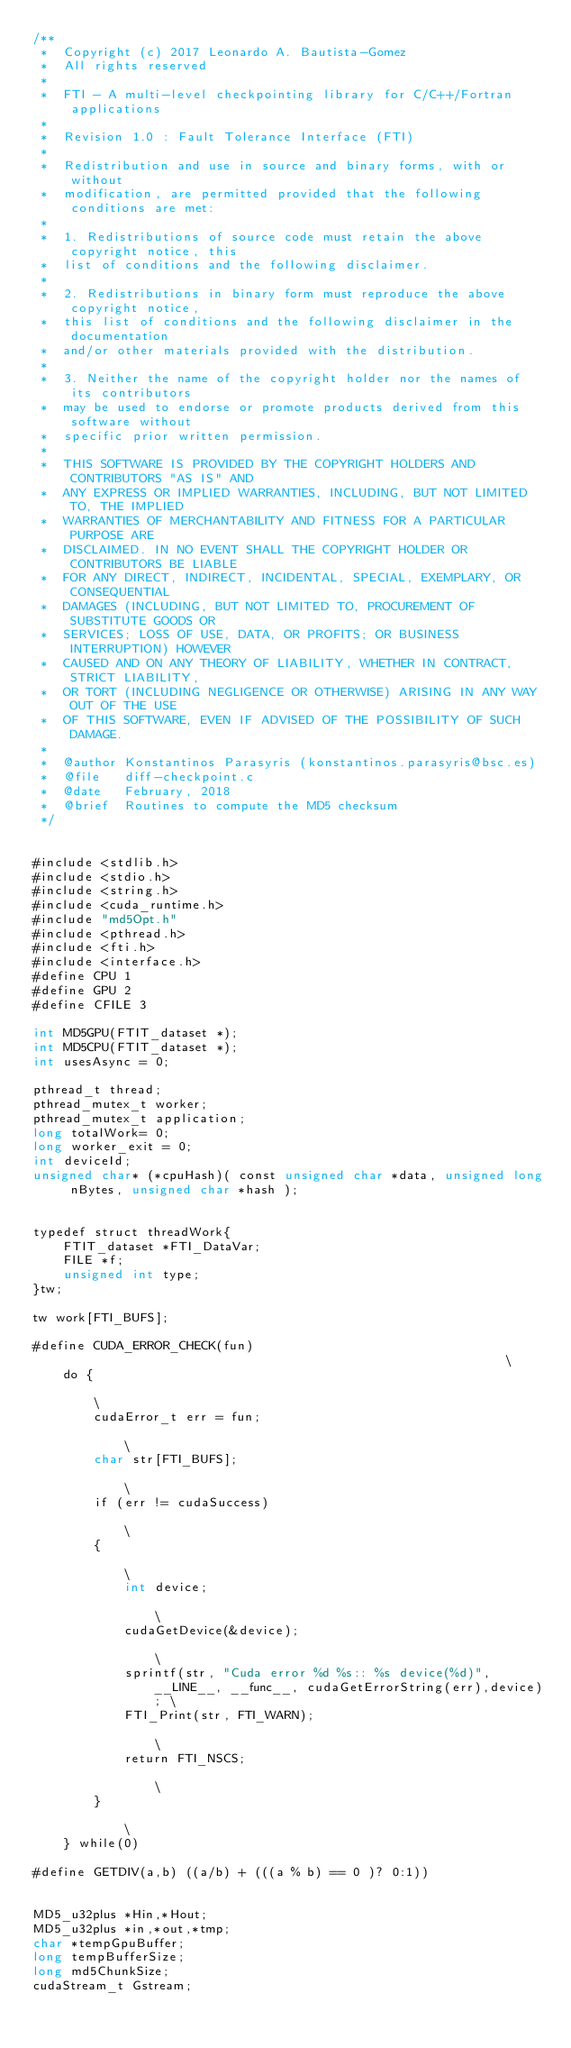<code> <loc_0><loc_0><loc_500><loc_500><_Cuda_>/**
 *  Copyright (c) 2017 Leonardo A. Bautista-Gomez
 *  All rights reserved
 *
 *  FTI - A multi-level checkpointing library for C/C++/Fortran applications
 *
 *  Revision 1.0 : Fault Tolerance Interface (FTI)
 *
 *  Redistribution and use in source and binary forms, with or without
 *  modification, are permitted provided that the following conditions are met:
 *
 *  1. Redistributions of source code must retain the above copyright notice, this
 *  list of conditions and the following disclaimer.
 *
 *  2. Redistributions in binary form must reproduce the above copyright notice,
 *  this list of conditions and the following disclaimer in the documentation
 *  and/or other materials provided with the distribution.
 *
 *  3. Neither the name of the copyright holder nor the names of its contributors
 *  may be used to endorse or promote products derived from this software without
 *  specific prior written permission.
 *
 *  THIS SOFTWARE IS PROVIDED BY THE COPYRIGHT HOLDERS AND CONTRIBUTORS "AS IS" AND
 *  ANY EXPRESS OR IMPLIED WARRANTIES, INCLUDING, BUT NOT LIMITED TO, THE IMPLIED
 *  WARRANTIES OF MERCHANTABILITY AND FITNESS FOR A PARTICULAR PURPOSE ARE
 *  DISCLAIMED. IN NO EVENT SHALL THE COPYRIGHT HOLDER OR CONTRIBUTORS BE LIABLE
 *  FOR ANY DIRECT, INDIRECT, INCIDENTAL, SPECIAL, EXEMPLARY, OR CONSEQUENTIAL
 *  DAMAGES (INCLUDING, BUT NOT LIMITED TO, PROCUREMENT OF SUBSTITUTE GOODS OR
 *  SERVICES; LOSS OF USE, DATA, OR PROFITS; OR BUSINESS INTERRUPTION) HOWEVER
 *  CAUSED AND ON ANY THEORY OF LIABILITY, WHETHER IN CONTRACT, STRICT LIABILITY,
 *  OR TORT (INCLUDING NEGLIGENCE OR OTHERWISE) ARISING IN ANY WAY OUT OF THE USE
 *  OF THIS SOFTWARE, EVEN IF ADVISED OF THE POSSIBILITY OF SUCH DAMAGE.
 *
 *  @author Konstantinos Parasyris (konstantinos.parasyris@bsc.es)
 *  @file   diff-checkpoint.c
 *  @date   February, 2018
 *  @brief  Routines to compute the MD5 checksum  
 */


#include <stdlib.h>
#include <stdio.h>
#include <string.h>
#include <cuda_runtime.h>
#include "md5Opt.h"
#include <pthread.h>
#include <fti.h>
#include <interface.h>
#define CPU 1
#define GPU 2
#define CFILE 3

int MD5GPU(FTIT_dataset *);
int MD5CPU(FTIT_dataset *);
int usesAsync = 0;

pthread_t thread;
pthread_mutex_t worker;
pthread_mutex_t application;
long totalWork= 0;
long worker_exit = 0;
int deviceId;
unsigned char* (*cpuHash)( const unsigned char *data, unsigned long nBytes, unsigned char *hash );


typedef struct threadWork{
    FTIT_dataset *FTI_DataVar;
    FILE *f;
    unsigned int type;
}tw;

tw work[FTI_BUFS];

#define CUDA_ERROR_CHECK(fun)                                                           \
    do {                                                                                    \
        cudaError_t err = fun;                                                              \
        char str[FTI_BUFS];                                                                 \
        if (err != cudaSuccess)                                                             \
        {                                                                                   \
            int device;                                                                       \
            cudaGetDevice(&device);                                                           \
            sprintf(str, "Cuda error %d %s:: %s device(%d)", __LINE__, __func__, cudaGetErrorString(err),device); \
            FTI_Print(str, FTI_WARN);                                                         \
            return FTI_NSCS;                                                                  \
        }                                                                                   \
    } while(0)

#define GETDIV(a,b) ((a/b) + (((a % b) == 0 )? 0:1))


MD5_u32plus *Hin,*Hout;
MD5_u32plus *in,*out,*tmp;
char *tempGpuBuffer; 
long tempBufferSize;
long md5ChunkSize;
cudaStream_t Gstream; 

</code> 